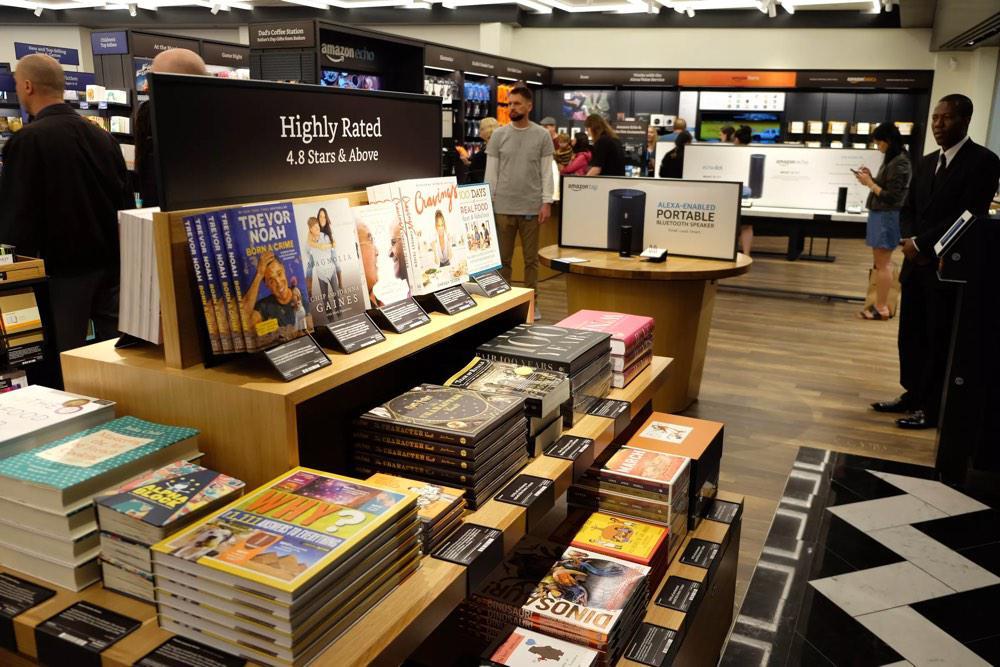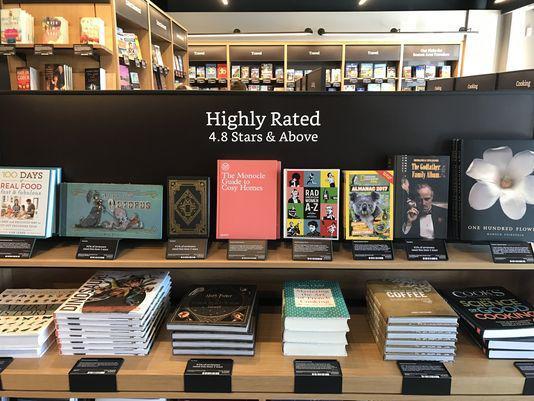The first image is the image on the left, the second image is the image on the right. Given the left and right images, does the statement "A person wearing black is standing on each side of one image, with a tiered stand of books topped with a horizontal black sign between the people." hold true? Answer yes or no. Yes. The first image is the image on the left, the second image is the image on the right. Assess this claim about the two images: "There are at least 5 stack of 4 books on the lower part of the display with the bottom of each book facing forward.". Correct or not? Answer yes or no. Yes. 